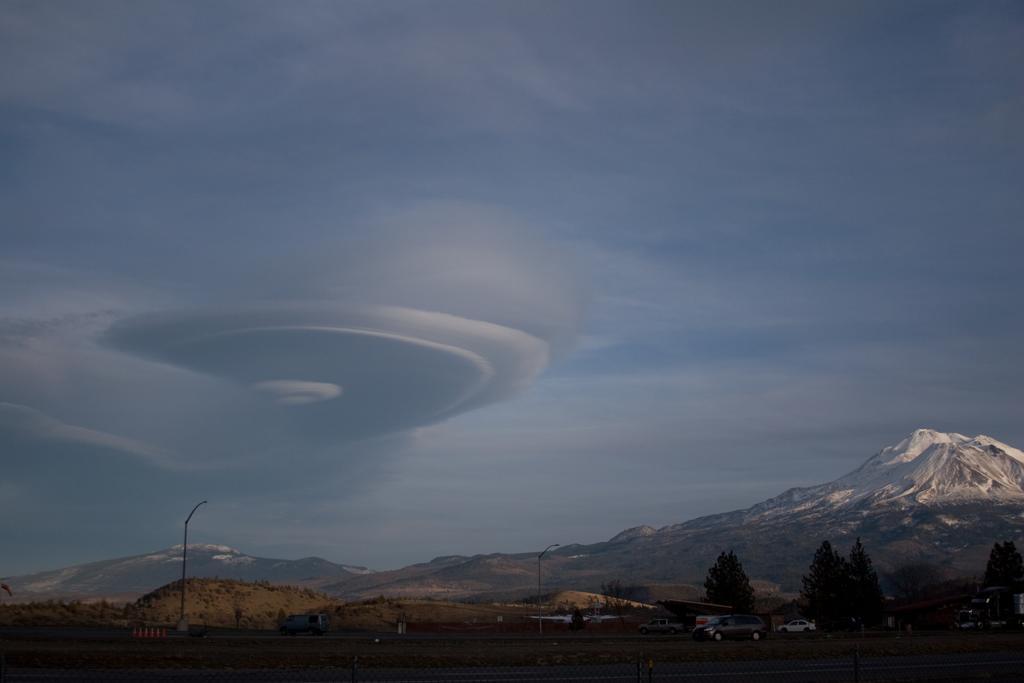Please provide a concise description of this image. In this image, I can see the mountains with the snow. These are the trees. I can see few cars, which are parked. I think these are the street lights. This is the sky with the clouds. 